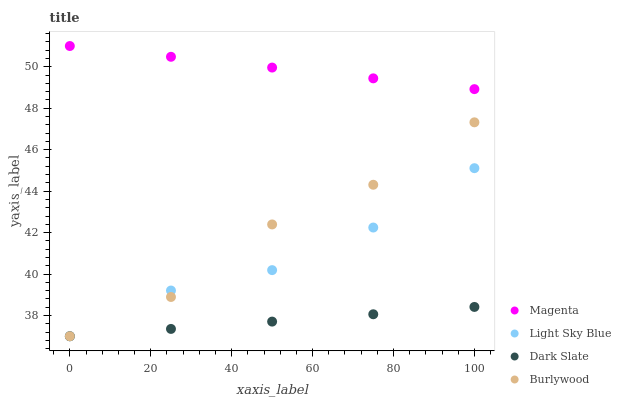Does Dark Slate have the minimum area under the curve?
Answer yes or no. Yes. Does Magenta have the maximum area under the curve?
Answer yes or no. Yes. Does Magenta have the minimum area under the curve?
Answer yes or no. No. Does Dark Slate have the maximum area under the curve?
Answer yes or no. No. Is Dark Slate the smoothest?
Answer yes or no. Yes. Is Burlywood the roughest?
Answer yes or no. Yes. Is Magenta the smoothest?
Answer yes or no. No. Is Magenta the roughest?
Answer yes or no. No. Does Burlywood have the lowest value?
Answer yes or no. Yes. Does Magenta have the lowest value?
Answer yes or no. No. Does Magenta have the highest value?
Answer yes or no. Yes. Does Dark Slate have the highest value?
Answer yes or no. No. Is Light Sky Blue less than Magenta?
Answer yes or no. Yes. Is Magenta greater than Light Sky Blue?
Answer yes or no. Yes. Does Dark Slate intersect Burlywood?
Answer yes or no. Yes. Is Dark Slate less than Burlywood?
Answer yes or no. No. Is Dark Slate greater than Burlywood?
Answer yes or no. No. Does Light Sky Blue intersect Magenta?
Answer yes or no. No. 